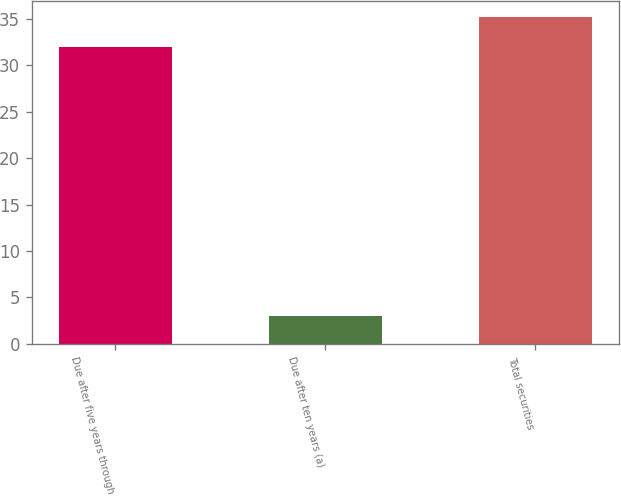Convert chart. <chart><loc_0><loc_0><loc_500><loc_500><bar_chart><fcel>Due after five years through<fcel>Due after ten years (a)<fcel>Total securities<nl><fcel>32<fcel>3<fcel>35.2<nl></chart> 